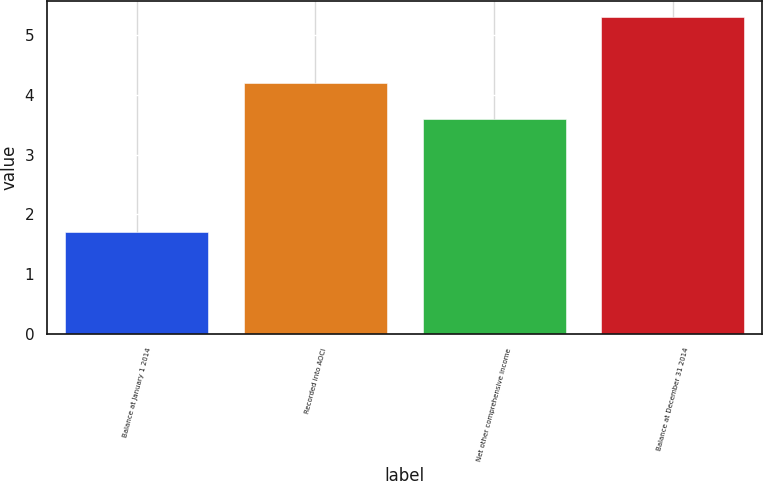<chart> <loc_0><loc_0><loc_500><loc_500><bar_chart><fcel>Balance at January 1 2014<fcel>Recorded into AOCI<fcel>Net other comprehensive income<fcel>Balance at December 31 2014<nl><fcel>1.7<fcel>4.2<fcel>3.6<fcel>5.3<nl></chart> 